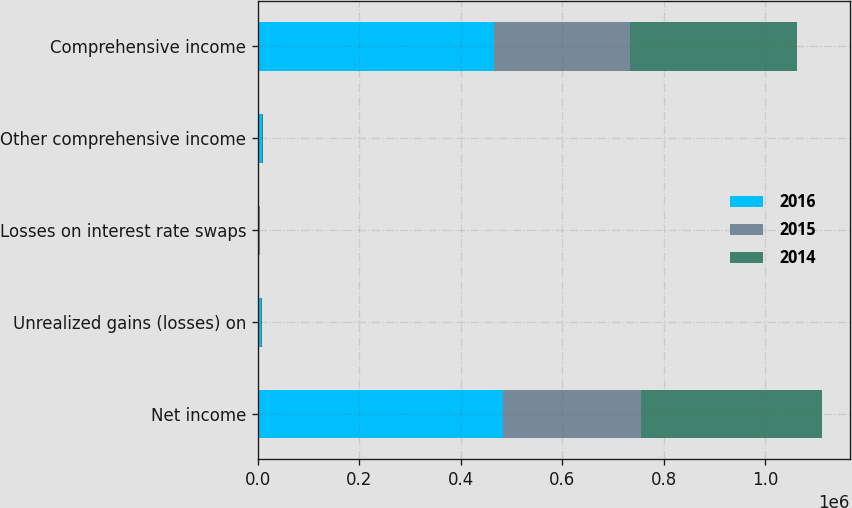<chart> <loc_0><loc_0><loc_500><loc_500><stacked_bar_chart><ecel><fcel>Net income<fcel>Unrealized gains (losses) on<fcel>Losses on interest rate swaps<fcel>Other comprehensive income<fcel>Comprehensive income<nl><fcel>2016<fcel>483273<fcel>5855<fcel>1586<fcel>7662<fcel>465419<nl><fcel>2015<fcel>271983<fcel>214<fcel>1678<fcel>593<fcel>267644<nl><fcel>2014<fcel>356111<fcel>1192<fcel>1685<fcel>1813<fcel>329565<nl></chart> 